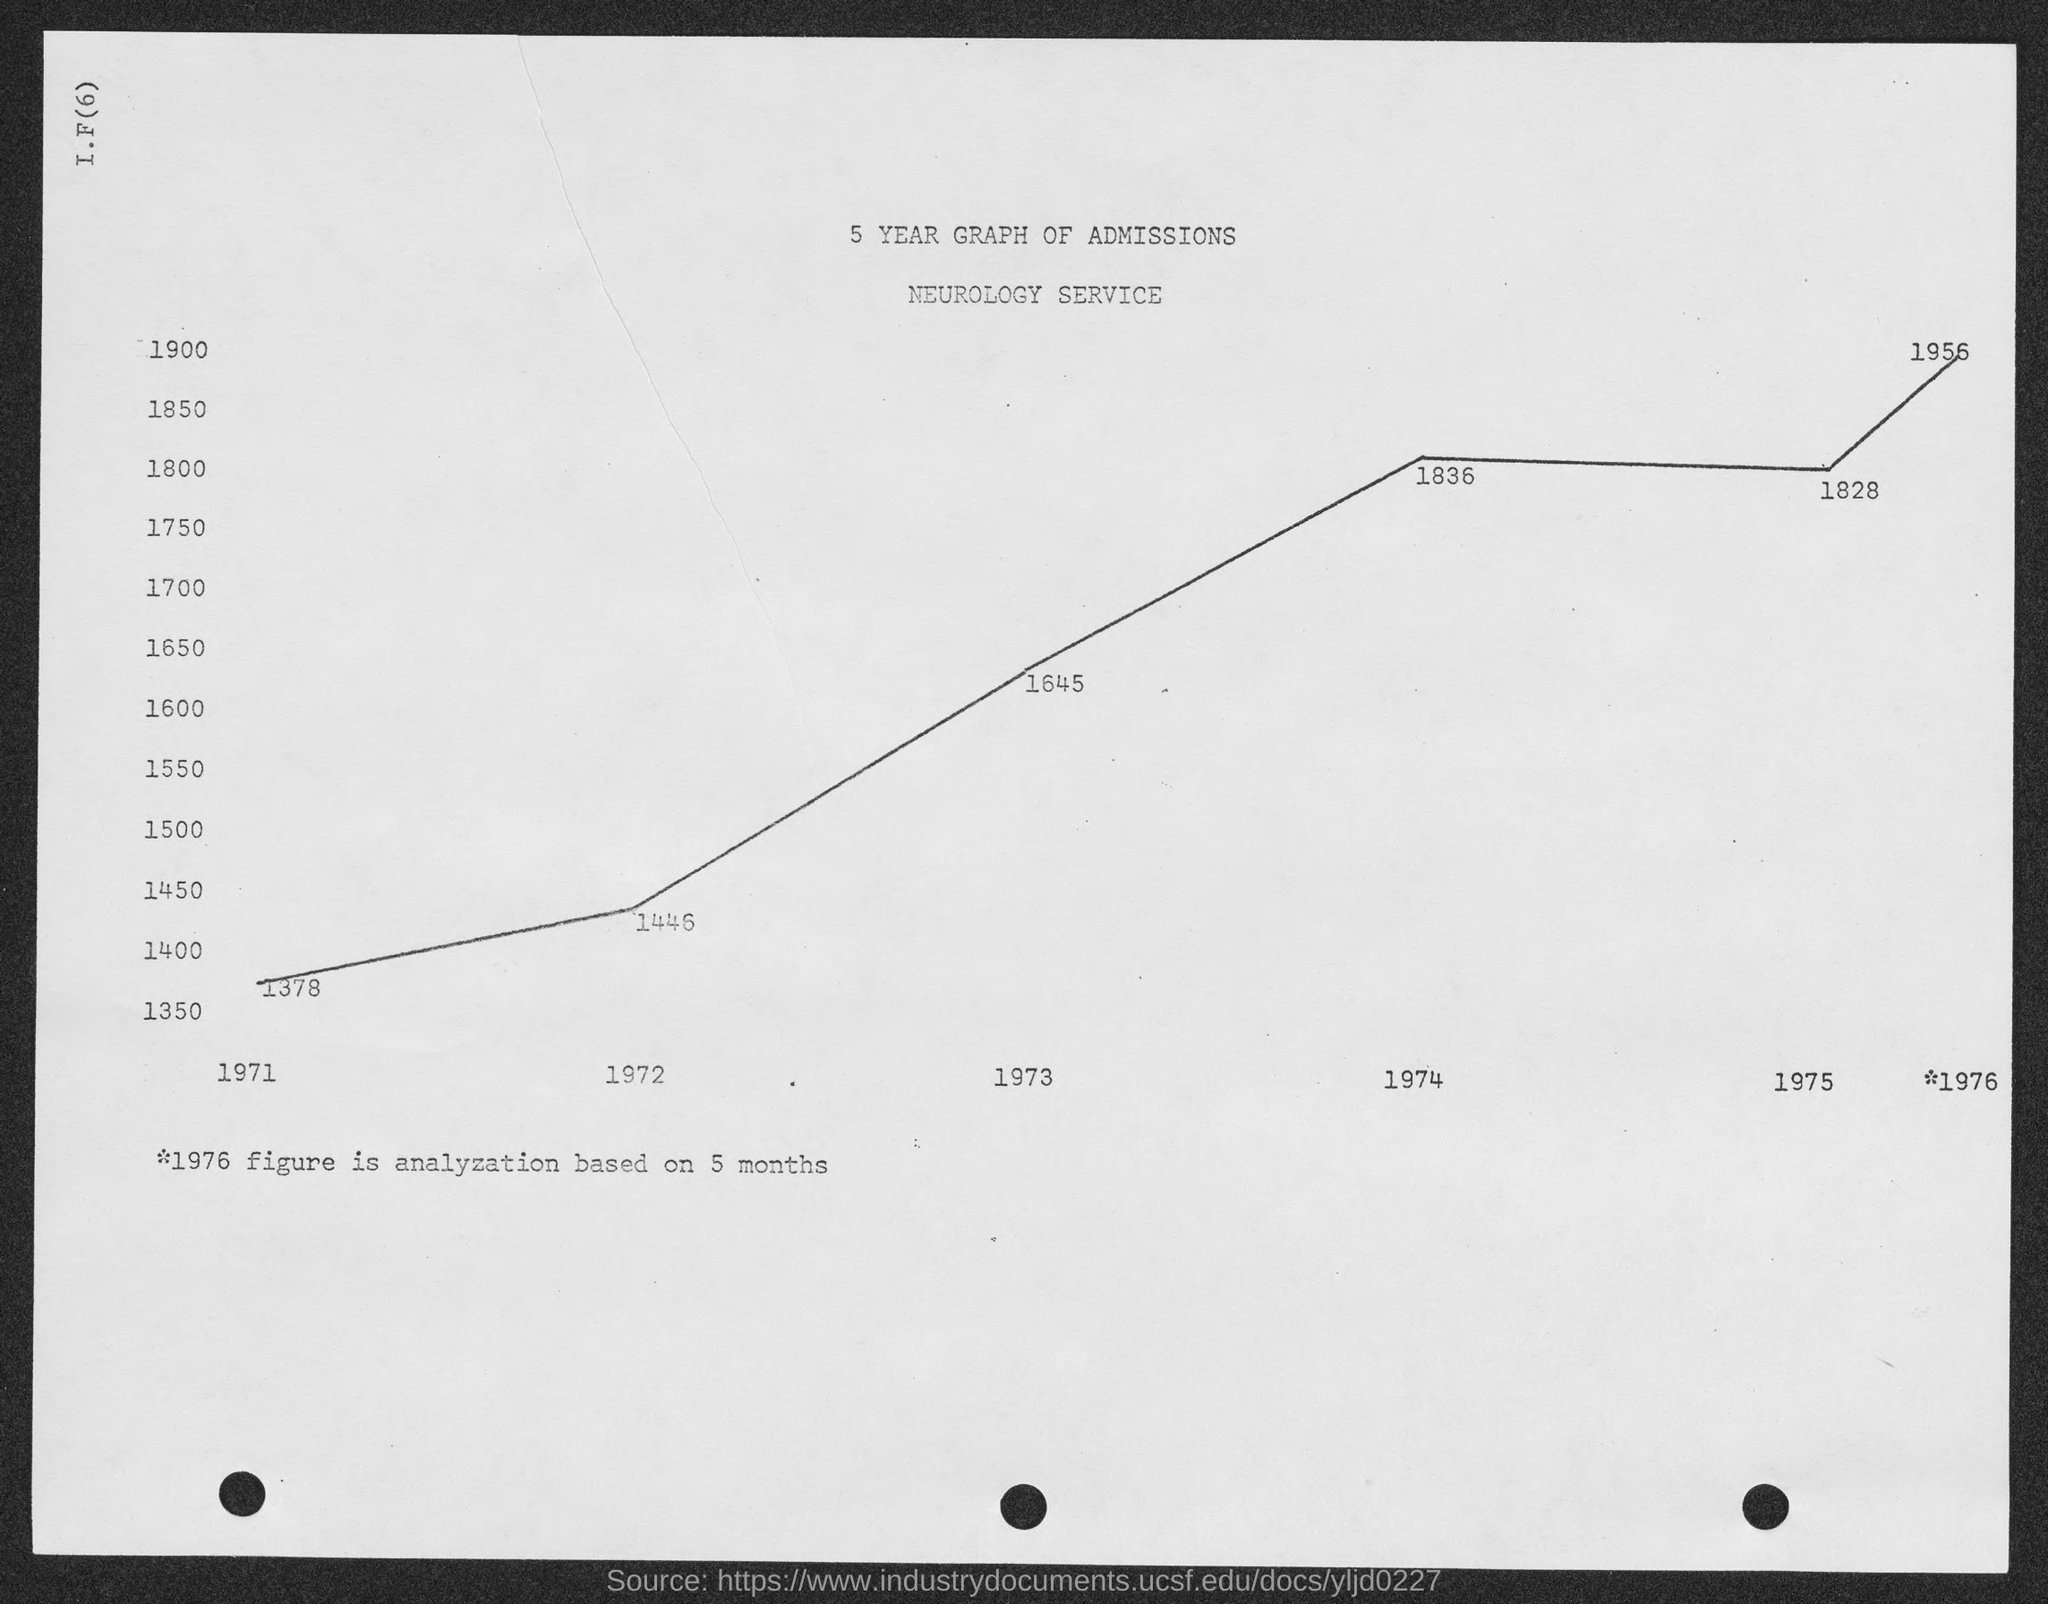What are the number of admissions in the year 1971 as shown in the graph ?
Provide a short and direct response. 1378. What are the number of admissions in the year 1972 as shown in the graph ?
Keep it short and to the point. 1446. What are the number of admissions in the year 1973 as shown in the graph ?
Provide a succinct answer. 1645. What are the number of admissions in the year 1974 as shown in the graph ?
Your answer should be compact. 1836. What are the number of admissions in the year 1975 as shown in the graph ?
Offer a terse response. 1828. 